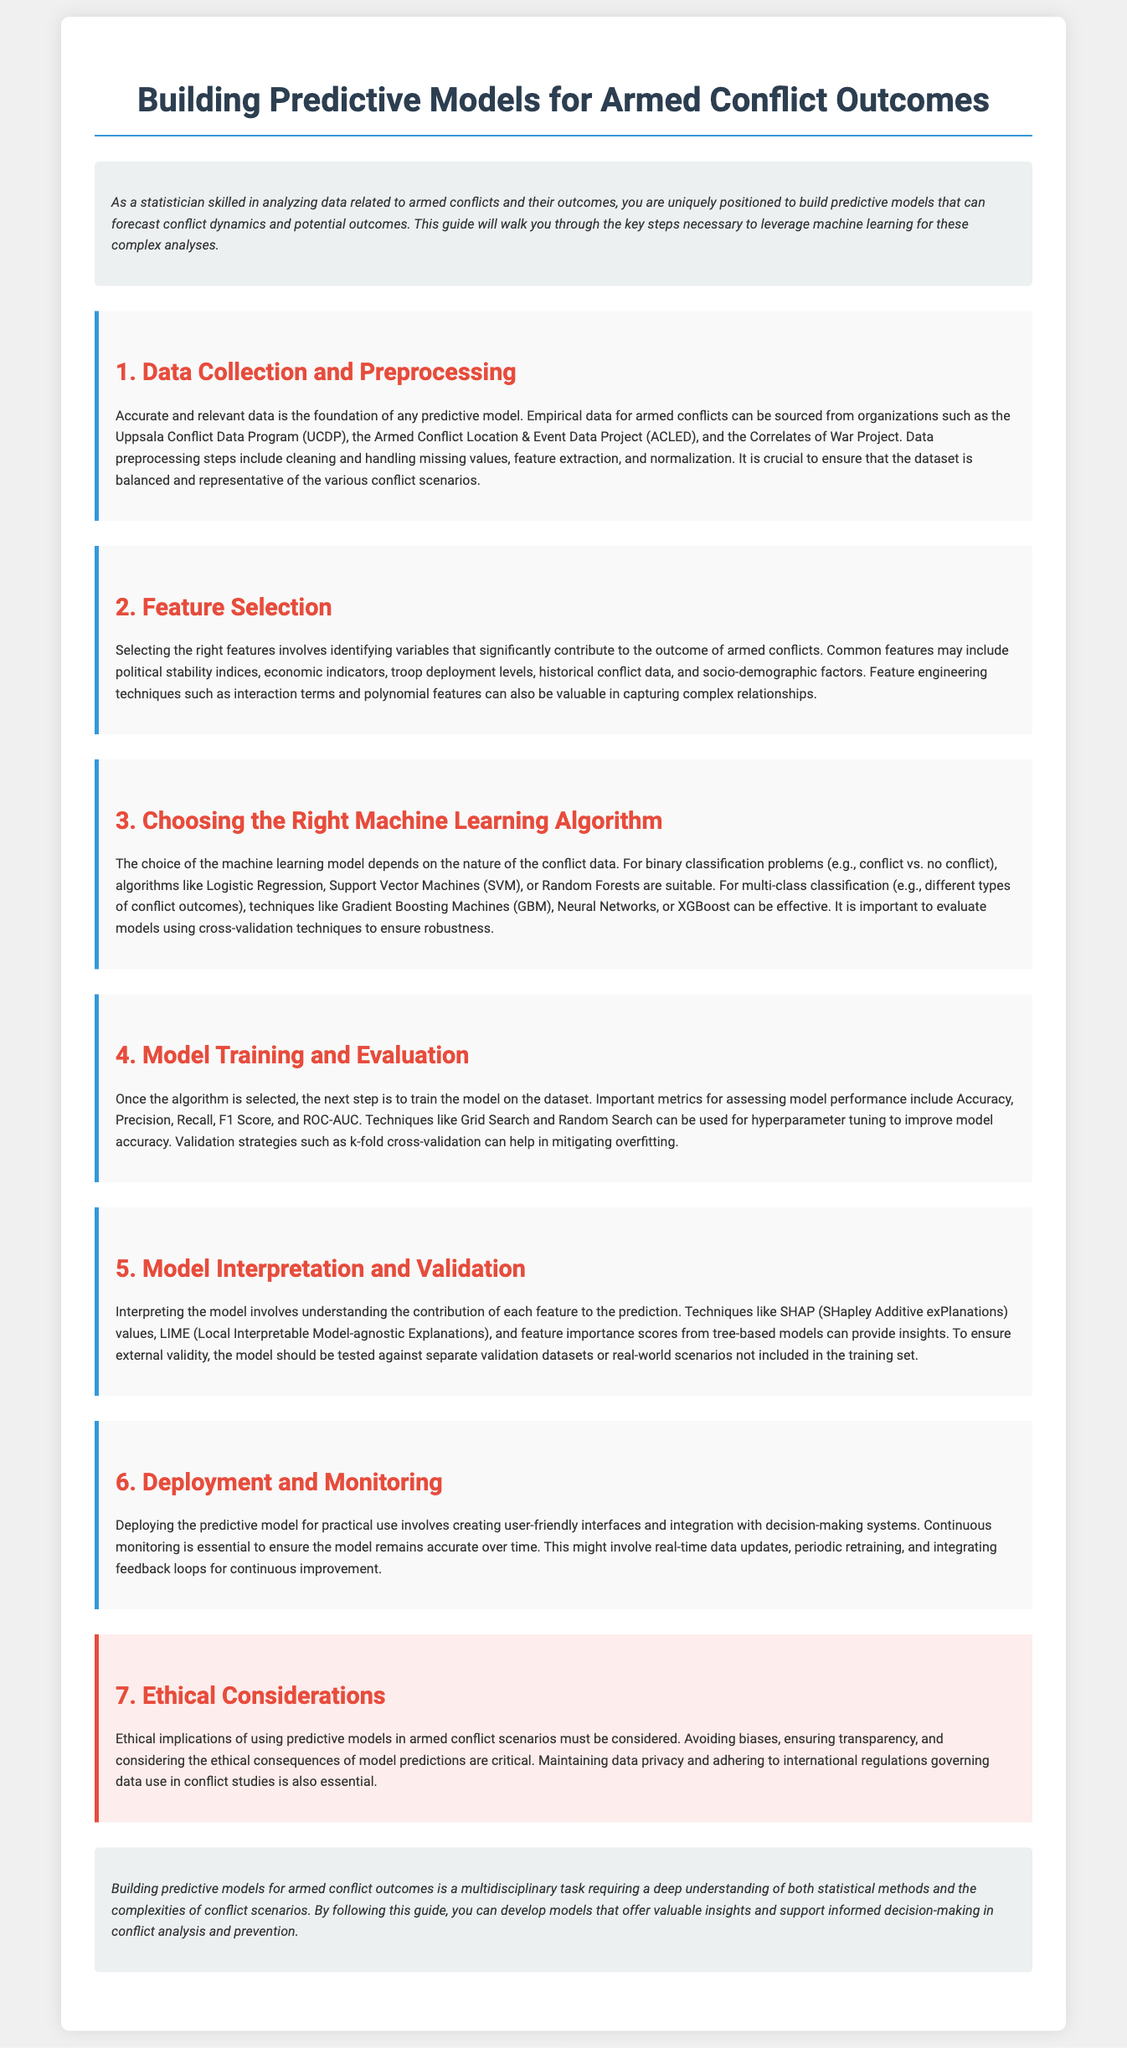what is the title of the document? The title of the document is displayed prominently at the top, indicating the main focus of the guide.
Answer: Building Predictive Models for Armed Conflict Outcomes who are the primary organizations mentioned for data sourcing? The document lists organizations providing empirical data for armed conflicts, highlighting their significance in the data collection process.
Answer: Uppsala Conflict Data Program, Armed Conflict Location & Event Data Project, Correlates of War Project which machine learning models are suitable for binary classification? The document specifies algorithm options for binary classification problems related to armed conflicts, indicated under the relevant section discussing model selection.
Answer: Logistic Regression, Support Vector Machines, Random Forests what is SHAP used for in model interpretation? The guide explains various techniques utilized for interpreting models and understanding feature significance, highlighting SHAP's role specifically.
Answer: SHapley Additive exPlanations what step involves hyperparameter tuning? The document outlines a clear sequence of steps necessary for building predictive models, pointing out where hyperparameter tuning fits into the process.
Answer: Model Training and Evaluation how many key sections are included in the guide? The document structure is explicitly laid out, with major sections numbered for clarity, reflecting the comprehensive nature of the guidance provided.
Answer: 7 what ethical consideration is emphasized in the document? Ethical implications related to using predictive models are discussed in a dedicated section that outlines crucial aspects to account for, emphasizing the need for responsibility.
Answer: Avoiding biases what is essential for model deployment? The document identifies important tasks to be undertaken during the deployment phase of predictive models, focusing on user integration and feedback systems.
Answer: Continuous monitoring 